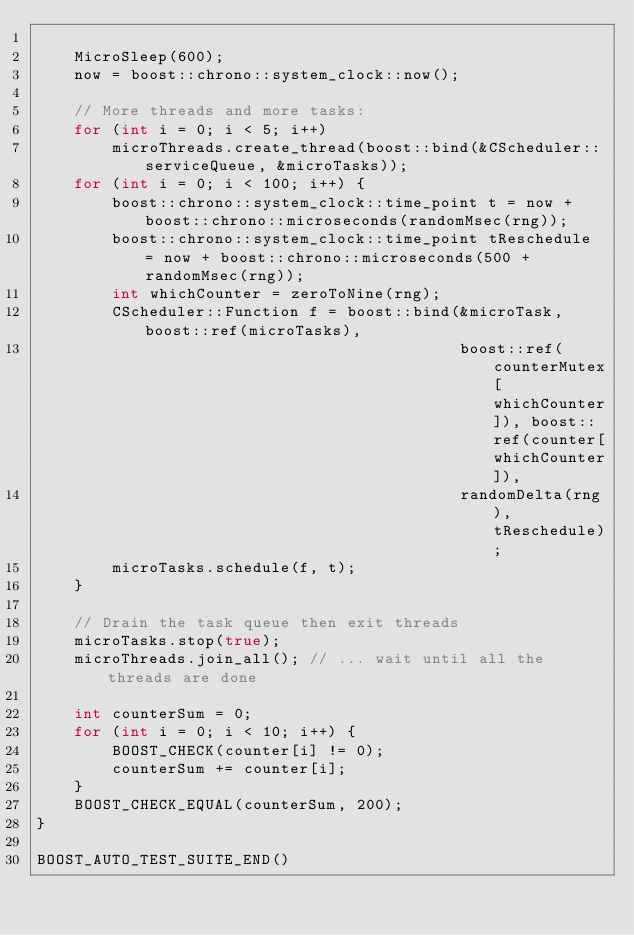<code> <loc_0><loc_0><loc_500><loc_500><_C++_>
    MicroSleep(600);
    now = boost::chrono::system_clock::now();

    // More threads and more tasks:
    for (int i = 0; i < 5; i++)
        microThreads.create_thread(boost::bind(&CScheduler::serviceQueue, &microTasks));
    for (int i = 0; i < 100; i++) {
        boost::chrono::system_clock::time_point t = now + boost::chrono::microseconds(randomMsec(rng));
        boost::chrono::system_clock::time_point tReschedule = now + boost::chrono::microseconds(500 + randomMsec(rng));
        int whichCounter = zeroToNine(rng);
        CScheduler::Function f = boost::bind(&microTask, boost::ref(microTasks),
                                             boost::ref(counterMutex[whichCounter]), boost::ref(counter[whichCounter]),
                                             randomDelta(rng), tReschedule);
        microTasks.schedule(f, t);
    }

    // Drain the task queue then exit threads
    microTasks.stop(true);
    microThreads.join_all(); // ... wait until all the threads are done

    int counterSum = 0;
    for (int i = 0; i < 10; i++) {
        BOOST_CHECK(counter[i] != 0);
        counterSum += counter[i];
    }
    BOOST_CHECK_EQUAL(counterSum, 200);
}

BOOST_AUTO_TEST_SUITE_END()
</code> 